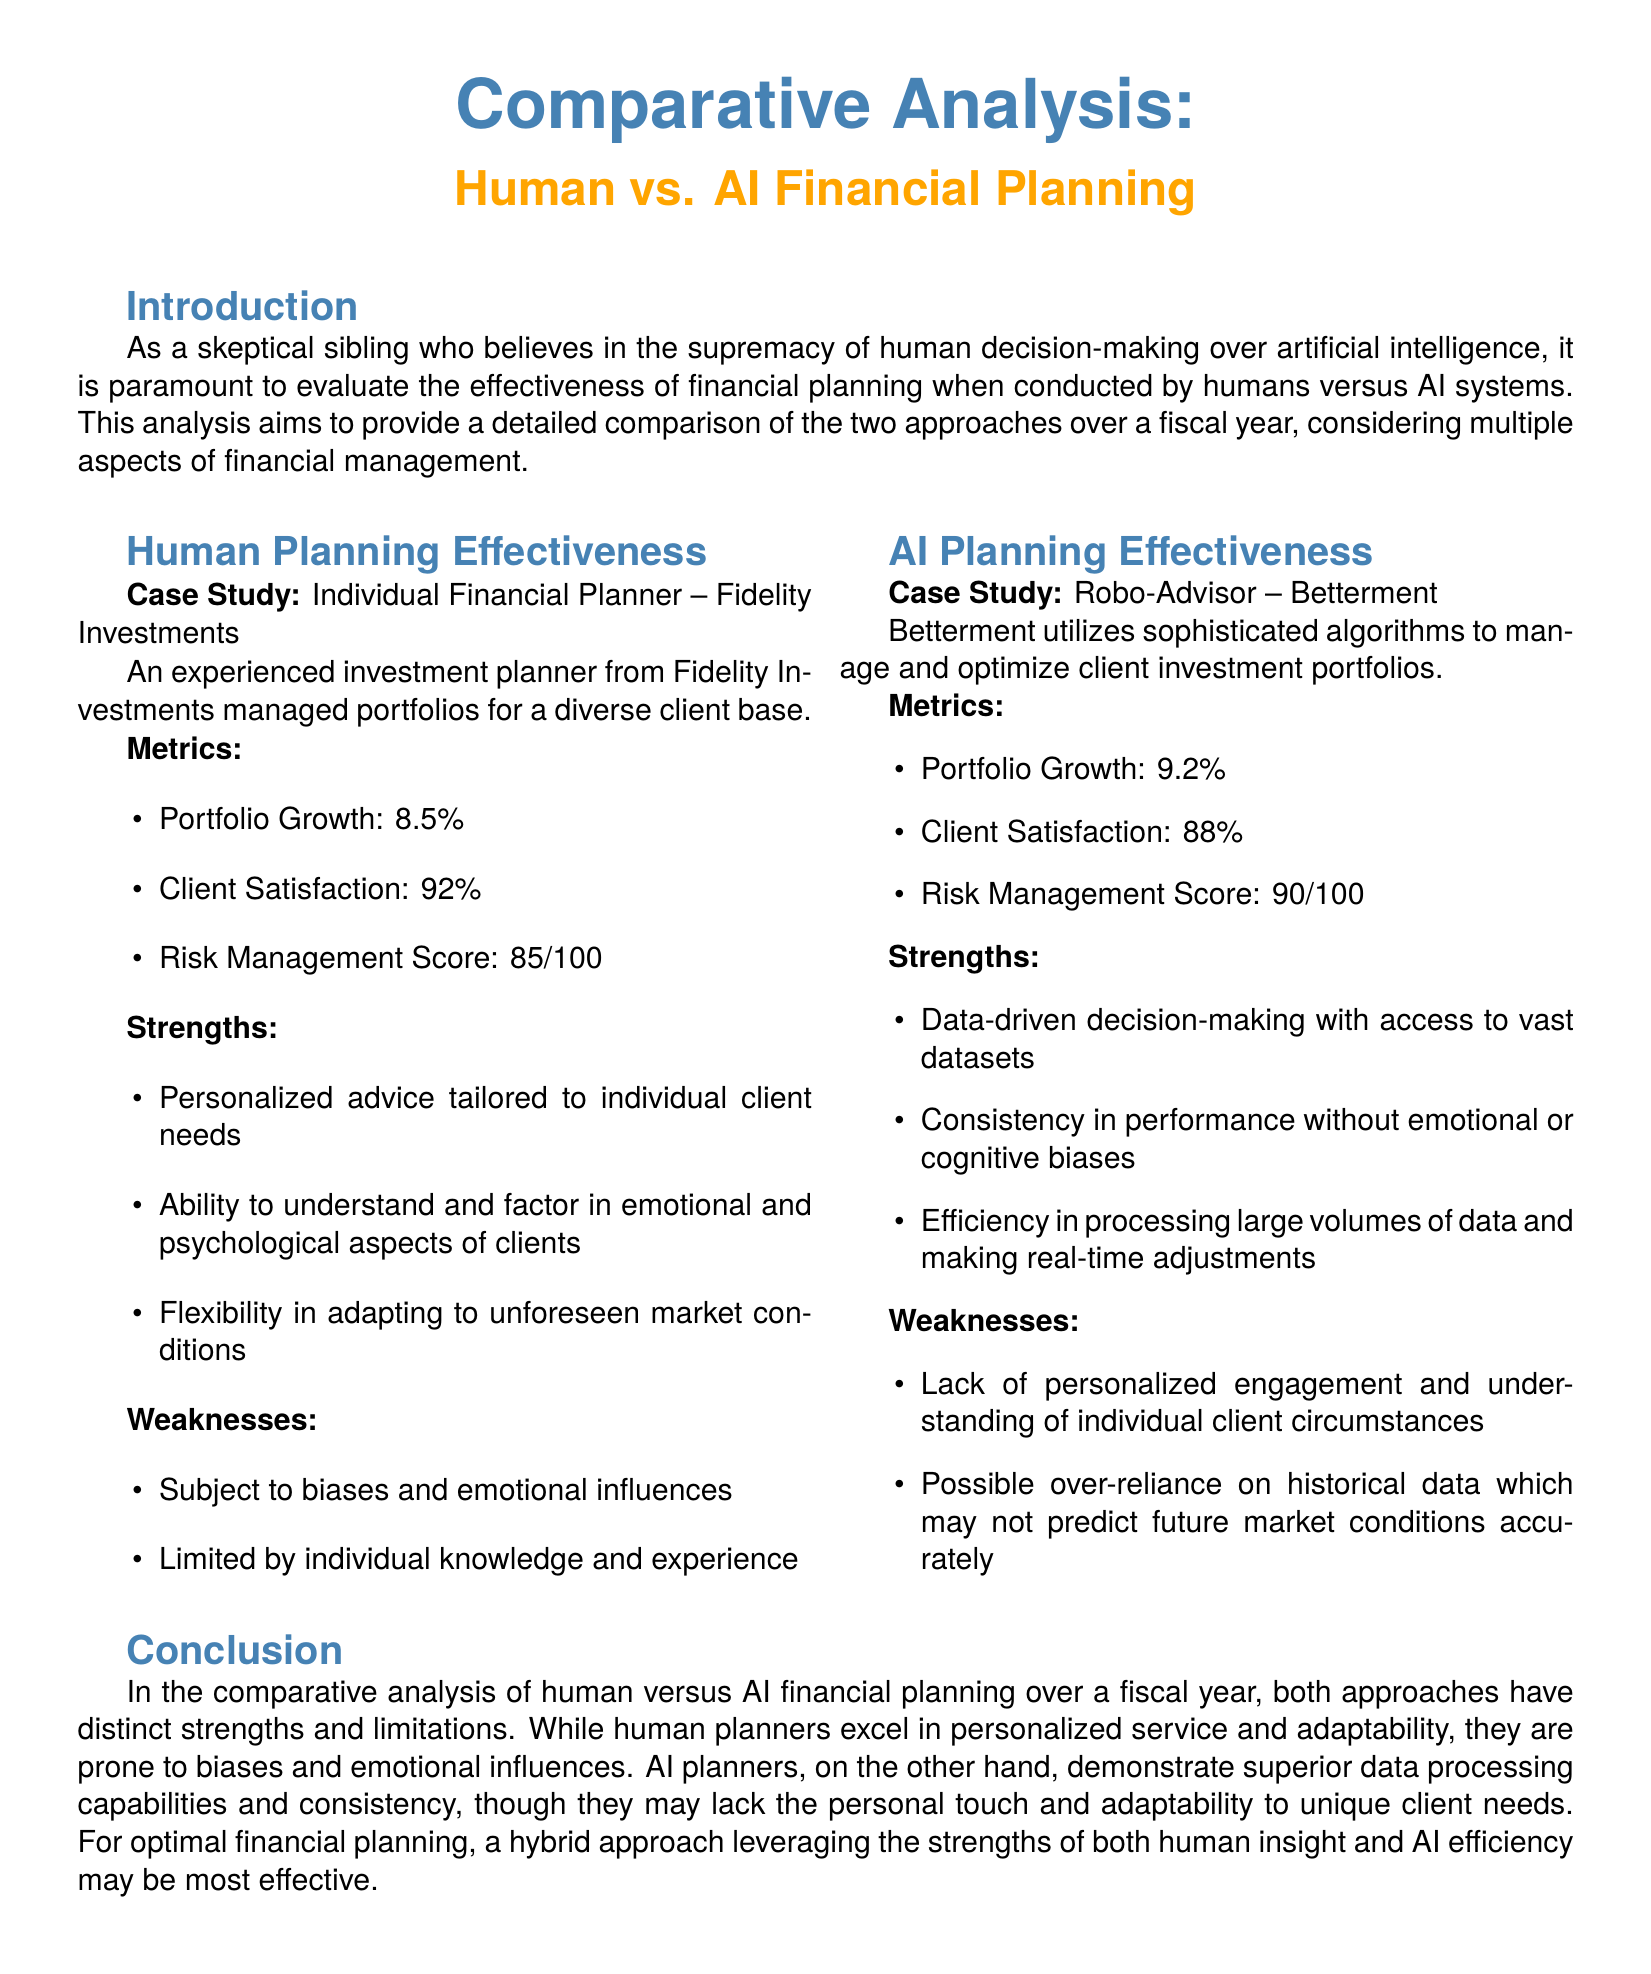What is the portfolio growth for human financial planning? The portfolio growth for human financial planning is mentioned in the document as 8.5%.
Answer: 8.5% What is the client satisfaction score for AI financial planning? The document states that the client satisfaction score for AI financial planning is 88%.
Answer: 88% Which financial planning approach has the highest risk management score? By comparing the risk management scores, AI financial planning has a score of 90, while human planning has a score of 85, making AI the higher one.
Answer: AI What is one strength of human financial planners? The document lists several strengths of human financial planners, one of which is their ability to provide personalized advice tailored to individual client needs.
Answer: Personalized advice What is one weakness of AI financial planning? The document highlights a weakness of AI financial planning, stating that it lacks personalized engagement and understanding of individual client circumstances.
Answer: Lack of personalized engagement What percentage of client satisfaction did human planners achieve? According to the document, human planners achieved a client satisfaction percentage of 92%.
Answer: 92% Which case study represents AI financial planning? The document specifies Betterment as the case study representing AI financial planning.
Answer: Betterment Which planning approach is more efficient in processing data? The document indicates that AI financial planning is efficient in processing large volumes of data and making real-time adjustments.
Answer: AI What is the overall conclusion about financial planning approaches? The conclusion emphasizes that a hybrid approach leveraging the strengths of both human insight and AI efficiency may be most effective.
Answer: Hybrid approach 